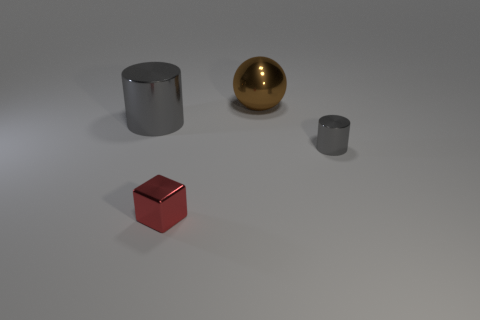There is a tiny gray object that is the same shape as the large gray thing; what is its material?
Your answer should be compact. Metal. What is the size of the cylinder on the right side of the big thing in front of the big thing on the right side of the small red shiny block?
Your answer should be very brief. Small. Are there any gray metal objects in front of the big gray cylinder?
Provide a short and direct response. Yes. What is the size of the red cube that is made of the same material as the brown ball?
Provide a short and direct response. Small. What number of small red shiny things have the same shape as the brown shiny object?
Provide a short and direct response. 0. Is the tiny red object made of the same material as the big thing in front of the brown ball?
Provide a short and direct response. Yes. Is the number of red objects in front of the cube greater than the number of gray shiny cylinders?
Your response must be concise. No. The thing that is the same color as the tiny cylinder is what shape?
Provide a short and direct response. Cylinder. Is there a small gray thing made of the same material as the small gray cylinder?
Your answer should be very brief. No. Is the material of the gray cylinder that is to the left of the metallic sphere the same as the cylinder that is in front of the big metallic cylinder?
Ensure brevity in your answer.  Yes. 